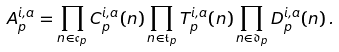Convert formula to latex. <formula><loc_0><loc_0><loc_500><loc_500>A _ { p } ^ { i , a } = \prod _ { n \in \mathfrak { c } _ { p } } C _ { p } ^ { i , a } ( n ) \prod _ { n \in \mathfrak { t } _ { p } } T _ { p } ^ { i , a } ( n ) \prod _ { n \in \mathfrak { d } _ { p } } D _ { p } ^ { i , a } ( n ) \, .</formula> 